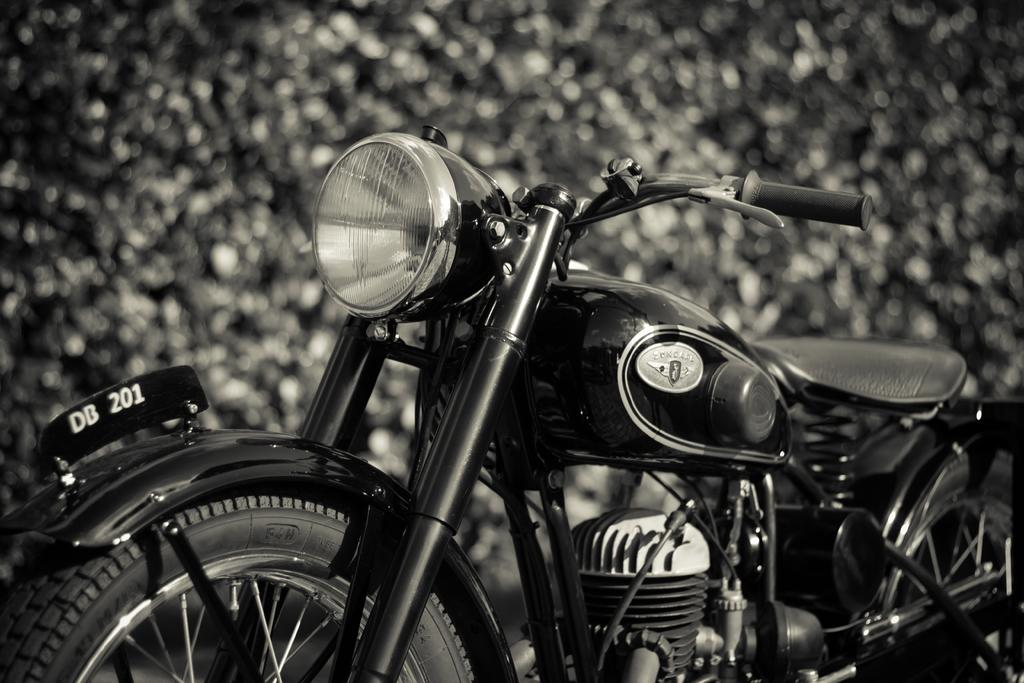What is the color scheme of the image? The image is black and white. What is the main subject in the foreground of the image? There is a motorbike in the foreground of the image. Can you describe the background of the image? The background of the image is blurred. How many leaves can be seen on the tramp in the image? There is no tramp or leaves present in the image. 